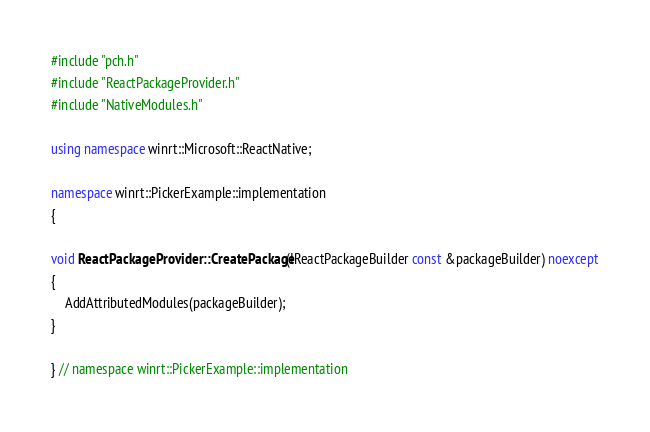<code> <loc_0><loc_0><loc_500><loc_500><_C++_>#include "pch.h"
#include "ReactPackageProvider.h"
#include "NativeModules.h"

using namespace winrt::Microsoft::ReactNative;

namespace winrt::PickerExample::implementation
{

void ReactPackageProvider::CreatePackage(IReactPackageBuilder const &packageBuilder) noexcept
{
    AddAttributedModules(packageBuilder);
}

} // namespace winrt::PickerExample::implementation


</code> 